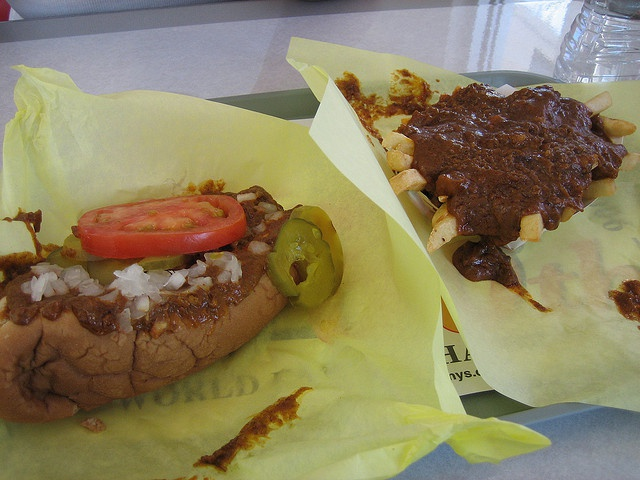Describe the objects in this image and their specific colors. I can see hot dog in brown, maroon, olive, and gray tones and bottle in brown, darkgray, gray, and lightblue tones in this image. 